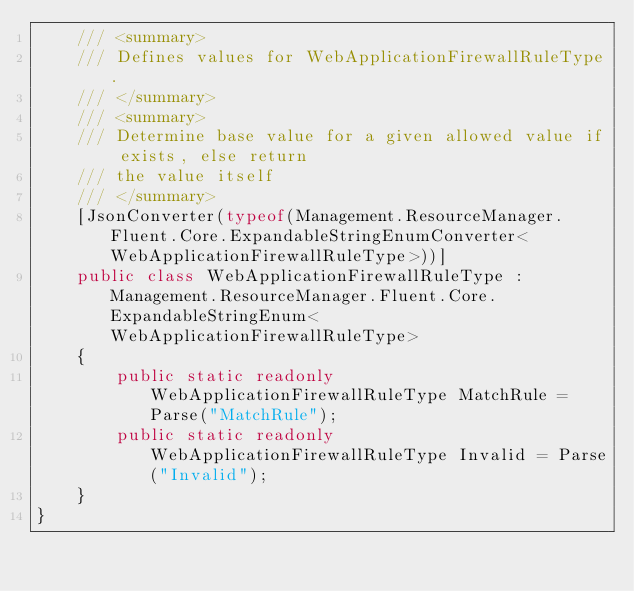<code> <loc_0><loc_0><loc_500><loc_500><_C#_>    /// <summary>
    /// Defines values for WebApplicationFirewallRuleType.
    /// </summary>
    /// <summary>
    /// Determine base value for a given allowed value if exists, else return
    /// the value itself
    /// </summary>
    [JsonConverter(typeof(Management.ResourceManager.Fluent.Core.ExpandableStringEnumConverter<WebApplicationFirewallRuleType>))]
    public class WebApplicationFirewallRuleType : Management.ResourceManager.Fluent.Core.ExpandableStringEnum<WebApplicationFirewallRuleType>
    {
        public static readonly WebApplicationFirewallRuleType MatchRule = Parse("MatchRule");
        public static readonly WebApplicationFirewallRuleType Invalid = Parse("Invalid");
    }
}
</code> 